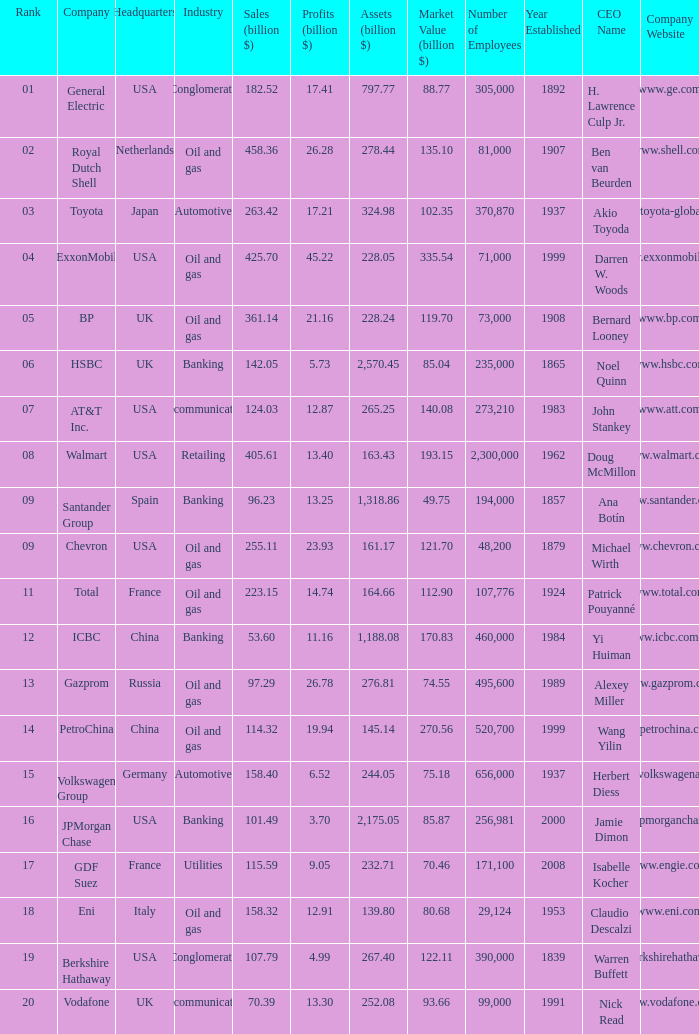Name the Sales (billion $) which have a Company of exxonmobil? 425.7. 